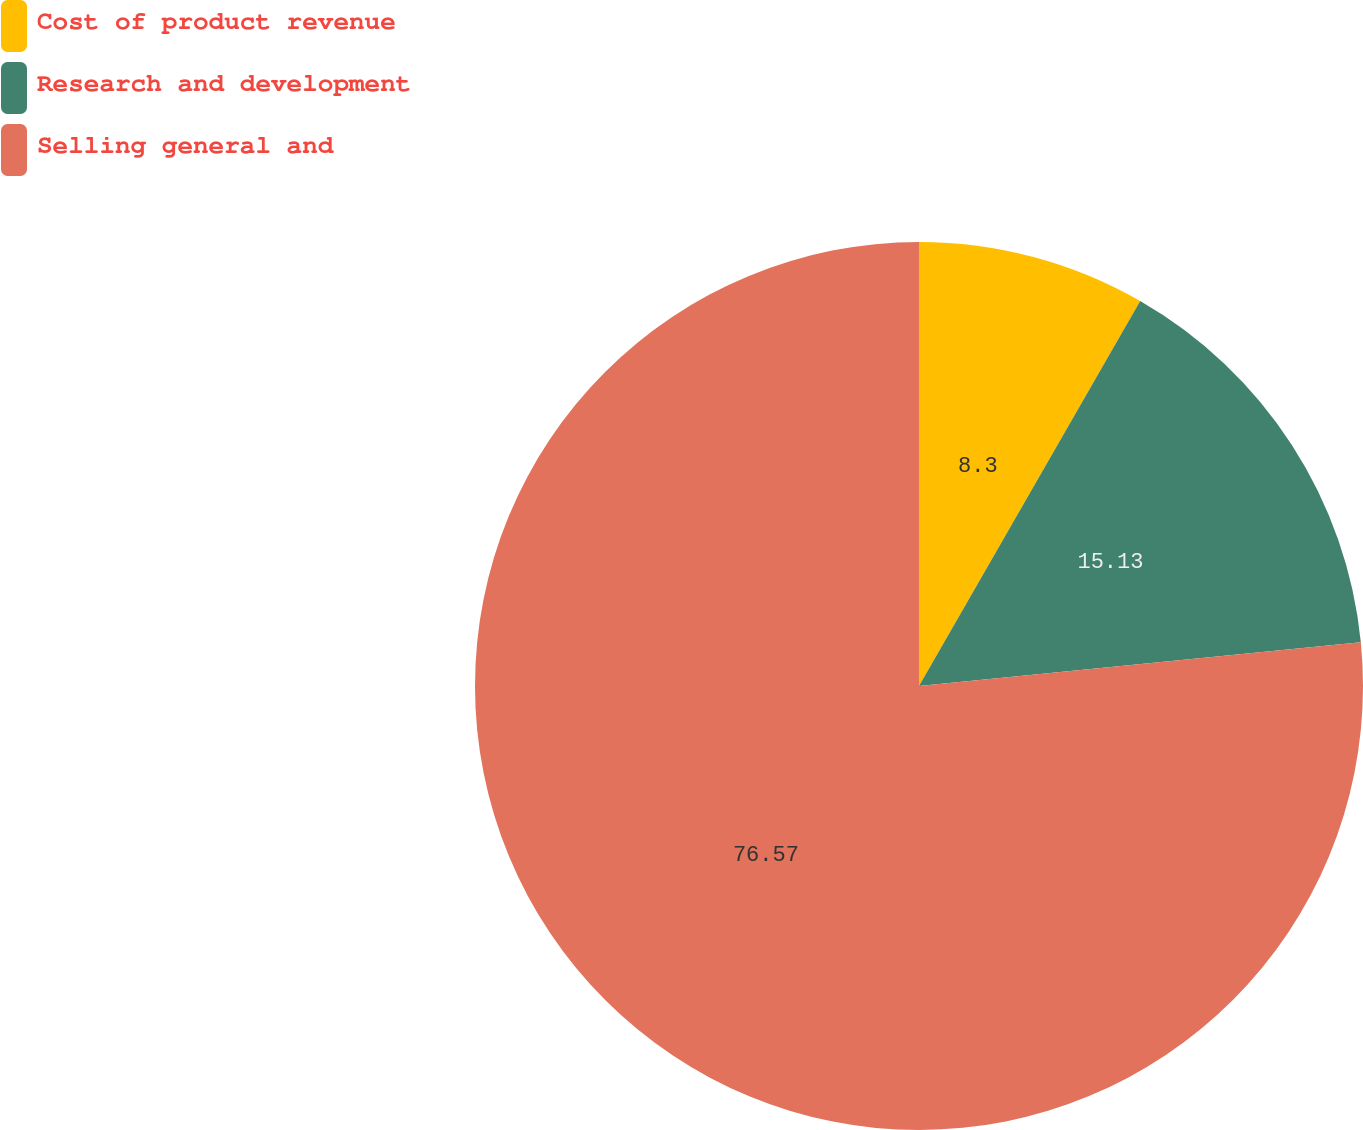Convert chart. <chart><loc_0><loc_0><loc_500><loc_500><pie_chart><fcel>Cost of product revenue<fcel>Research and development<fcel>Selling general and<nl><fcel>8.3%<fcel>15.13%<fcel>76.57%<nl></chart> 